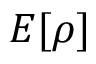Convert formula to latex. <formula><loc_0><loc_0><loc_500><loc_500>E [ \rho ]</formula> 